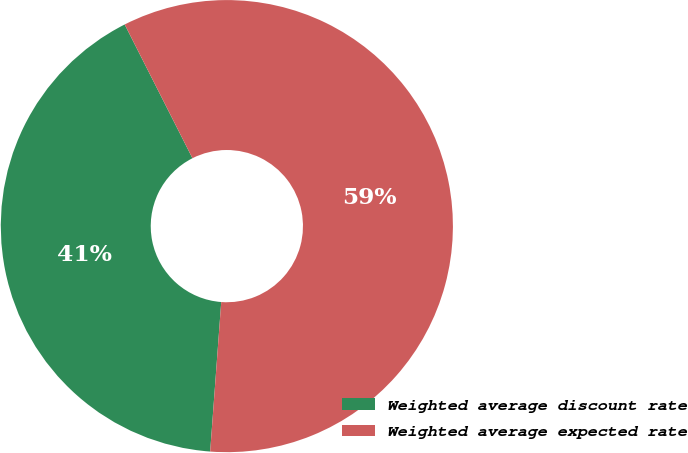<chart> <loc_0><loc_0><loc_500><loc_500><pie_chart><fcel>Weighted average discount rate<fcel>Weighted average expected rate<nl><fcel>41.36%<fcel>58.64%<nl></chart> 